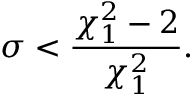Convert formula to latex. <formula><loc_0><loc_0><loc_500><loc_500>\sigma < \frac { \chi _ { 1 } ^ { 2 } - 2 } { \chi _ { 1 } ^ { 2 } } .</formula> 